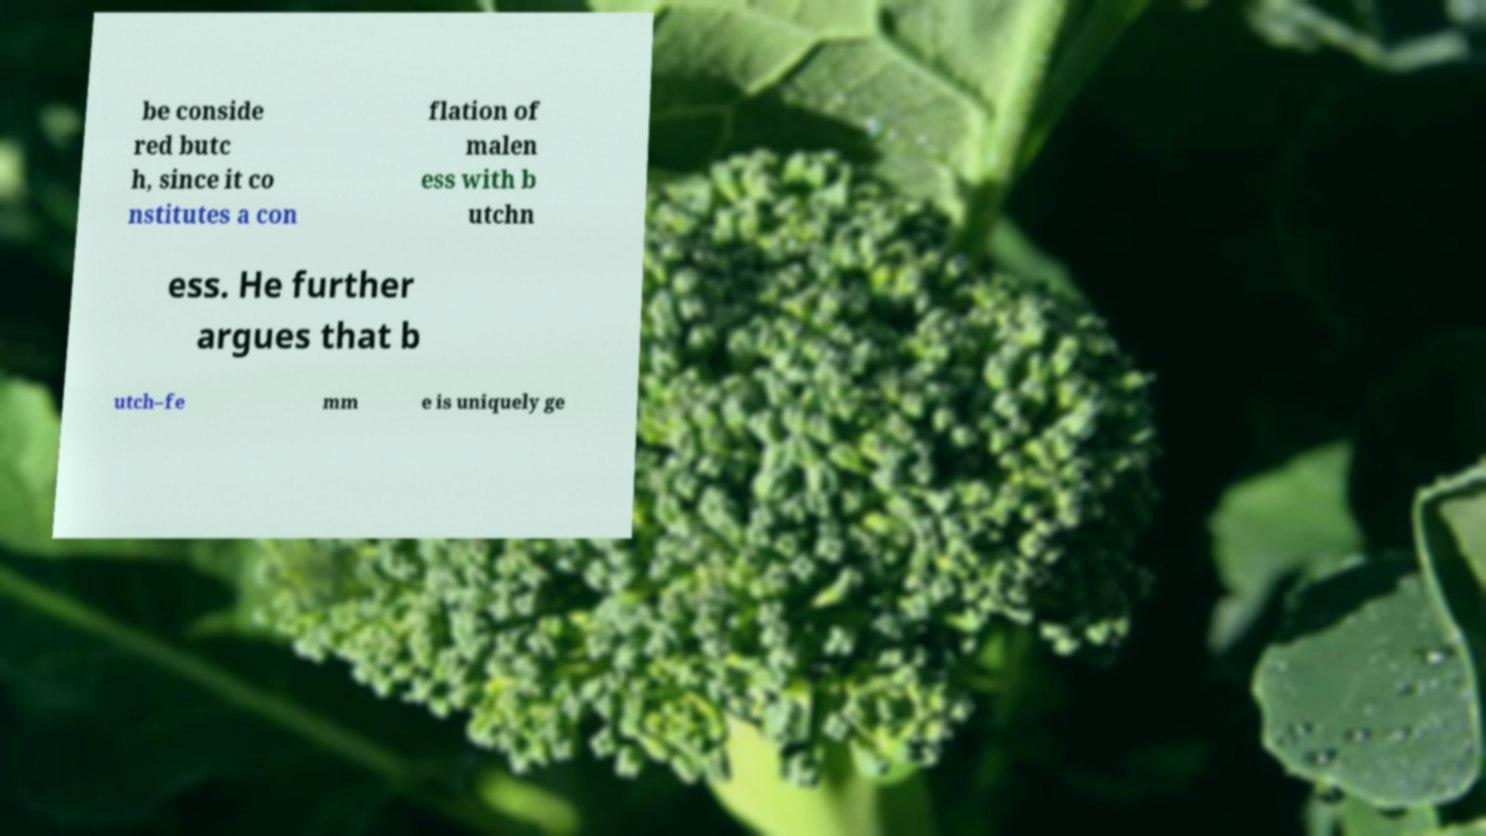Can you accurately transcribe the text from the provided image for me? be conside red butc h, since it co nstitutes a con flation of malen ess with b utchn ess. He further argues that b utch–fe mm e is uniquely ge 